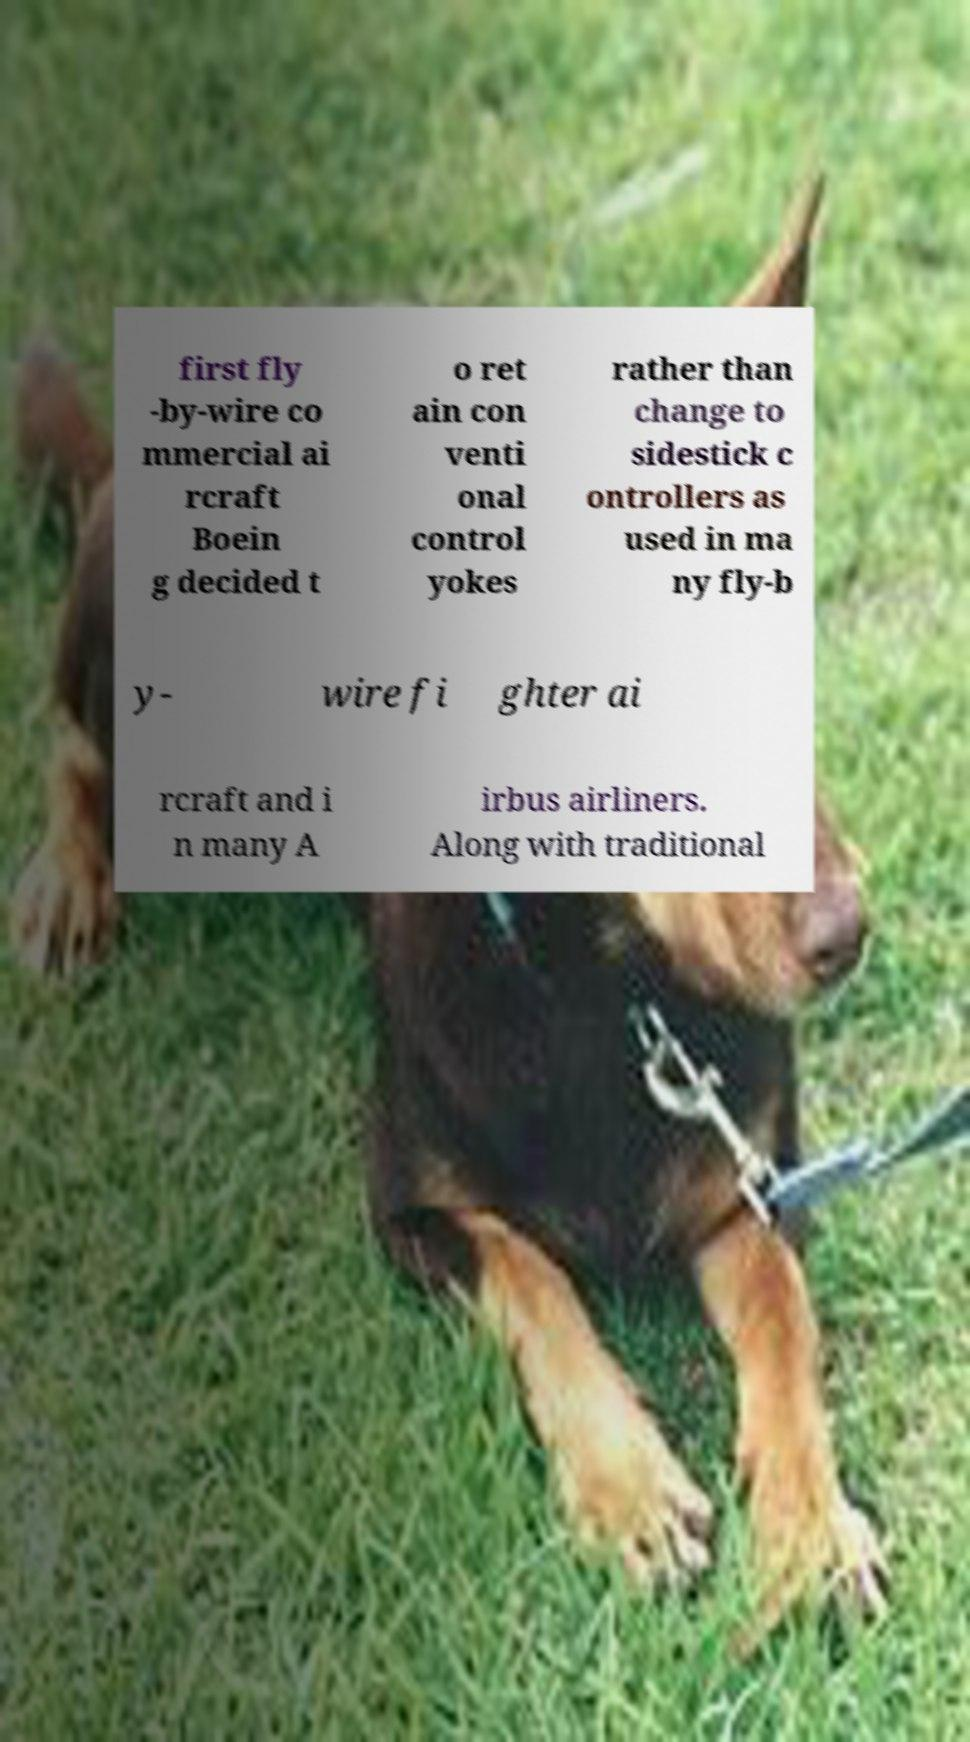Can you read and provide the text displayed in the image?This photo seems to have some interesting text. Can you extract and type it out for me? first fly -by-wire co mmercial ai rcraft Boein g decided t o ret ain con venti onal control yokes rather than change to sidestick c ontrollers as used in ma ny fly-b y- wire fi ghter ai rcraft and i n many A irbus airliners. Along with traditional 